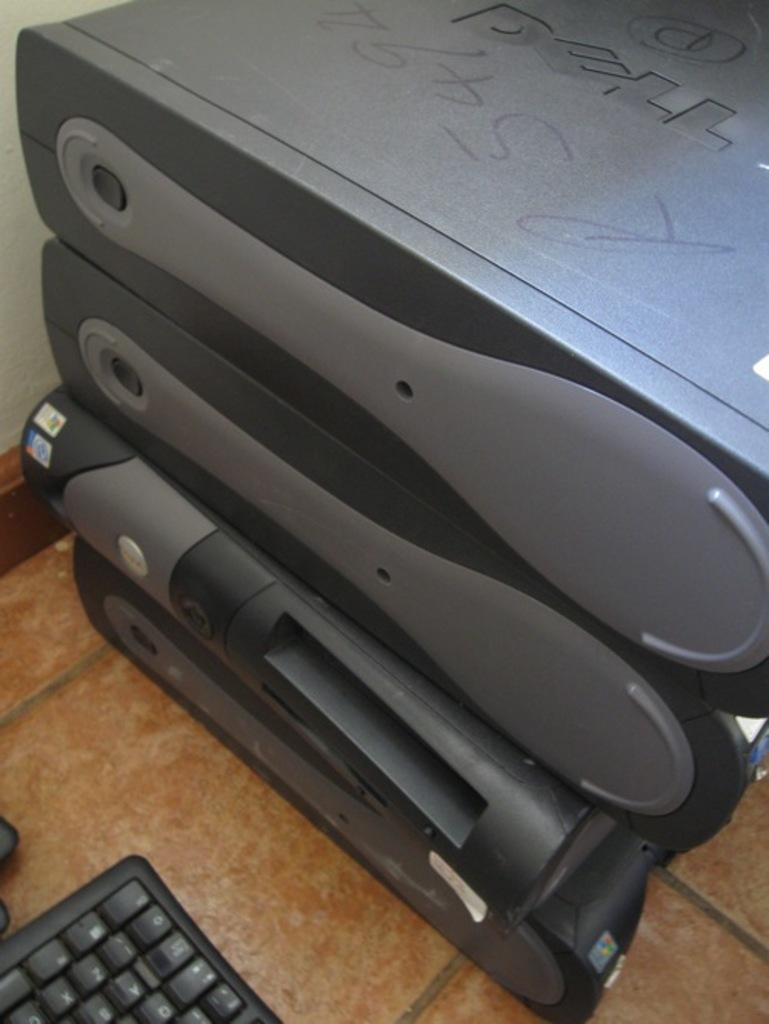Describe this image in one or two sentences. In this image there is a CPU. Beside that there is a keyboard on the floor. 